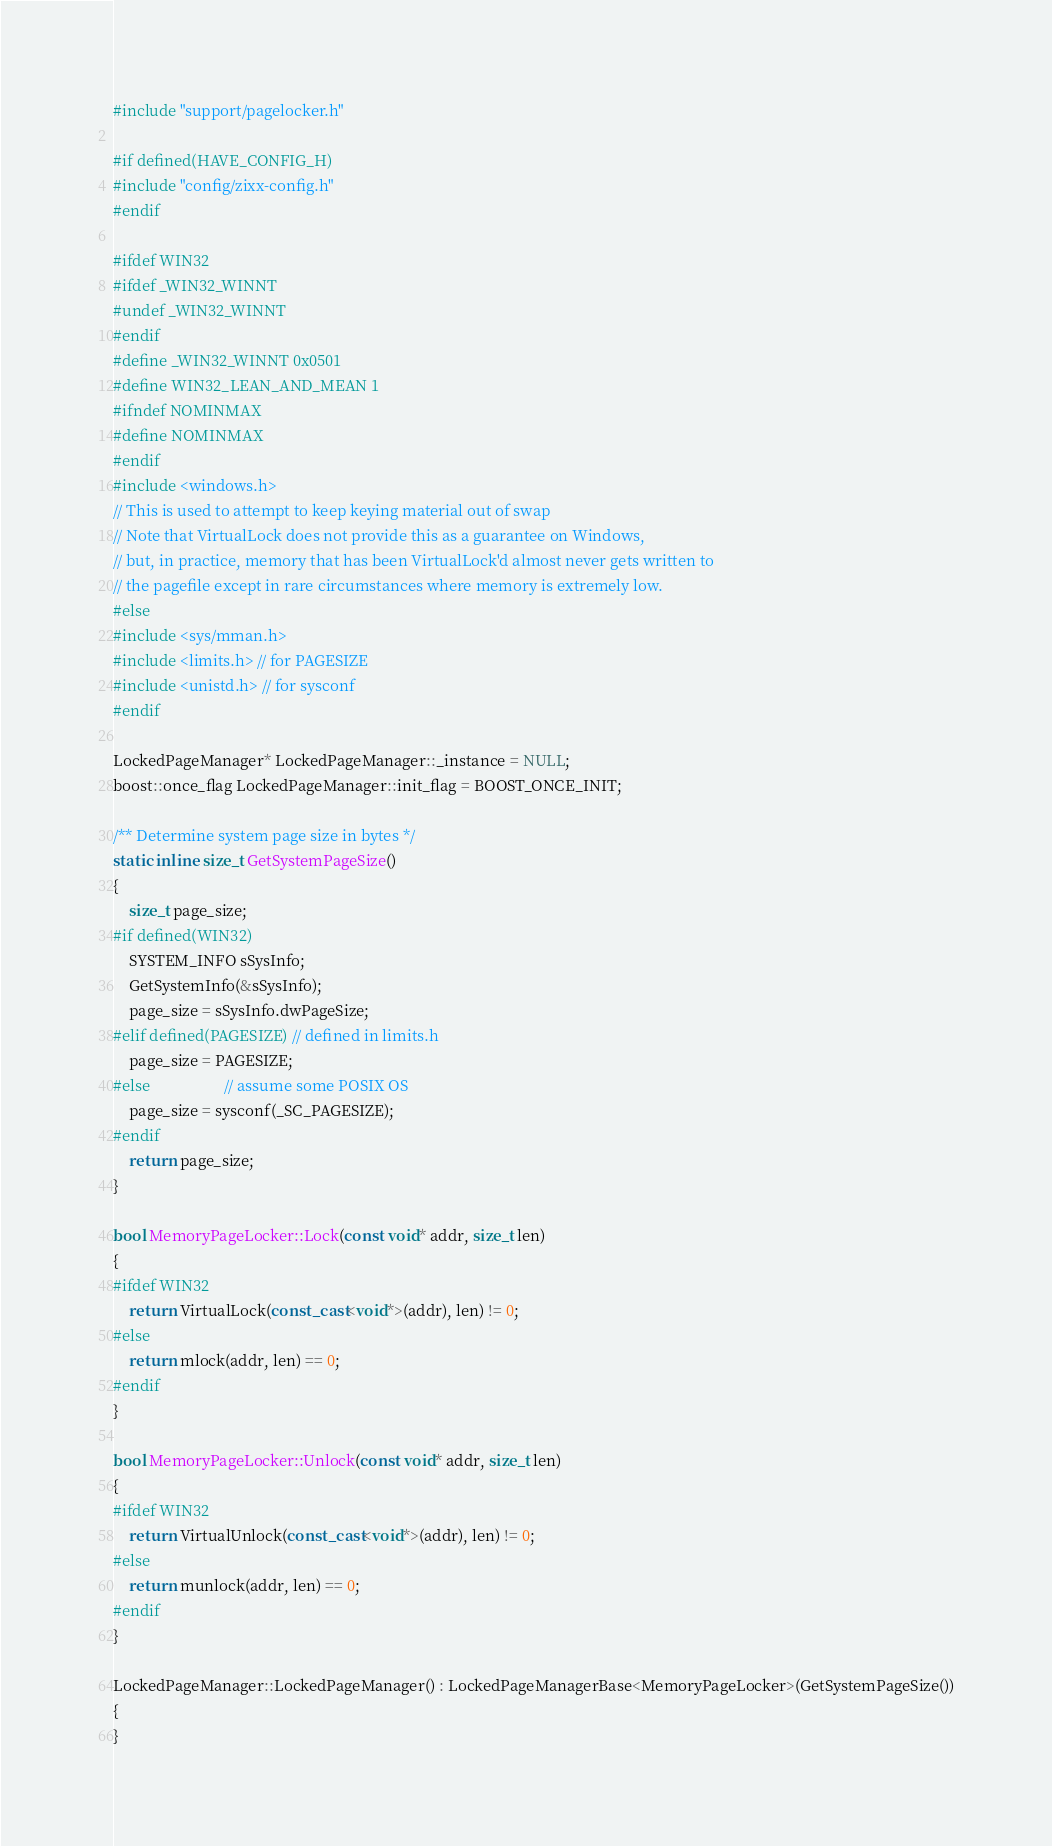<code> <loc_0><loc_0><loc_500><loc_500><_C++_>#include "support/pagelocker.h"

#if defined(HAVE_CONFIG_H)
#include "config/zixx-config.h"
#endif

#ifdef WIN32
#ifdef _WIN32_WINNT
#undef _WIN32_WINNT
#endif
#define _WIN32_WINNT 0x0501
#define WIN32_LEAN_AND_MEAN 1
#ifndef NOMINMAX
#define NOMINMAX
#endif
#include <windows.h>
// This is used to attempt to keep keying material out of swap
// Note that VirtualLock does not provide this as a guarantee on Windows,
// but, in practice, memory that has been VirtualLock'd almost never gets written to
// the pagefile except in rare circumstances where memory is extremely low.
#else
#include <sys/mman.h>
#include <limits.h> // for PAGESIZE
#include <unistd.h> // for sysconf
#endif

LockedPageManager* LockedPageManager::_instance = NULL;
boost::once_flag LockedPageManager::init_flag = BOOST_ONCE_INIT;

/** Determine system page size in bytes */
static inline size_t GetSystemPageSize()
{
    size_t page_size;
#if defined(WIN32)
    SYSTEM_INFO sSysInfo;
    GetSystemInfo(&sSysInfo);
    page_size = sSysInfo.dwPageSize;
#elif defined(PAGESIZE) // defined in limits.h
    page_size = PAGESIZE;
#else                   // assume some POSIX OS
    page_size = sysconf(_SC_PAGESIZE);
#endif
    return page_size;
}

bool MemoryPageLocker::Lock(const void* addr, size_t len)
{
#ifdef WIN32
    return VirtualLock(const_cast<void*>(addr), len) != 0;
#else
    return mlock(addr, len) == 0;
#endif
}

bool MemoryPageLocker::Unlock(const void* addr, size_t len)
{
#ifdef WIN32
    return VirtualUnlock(const_cast<void*>(addr), len) != 0;
#else
    return munlock(addr, len) == 0;
#endif
}

LockedPageManager::LockedPageManager() : LockedPageManagerBase<MemoryPageLocker>(GetSystemPageSize())
{
}
</code> 